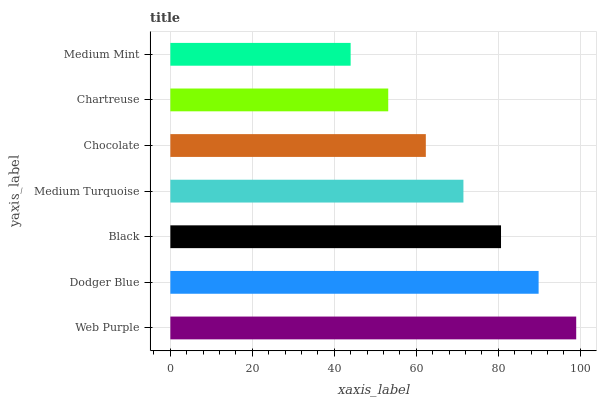Is Medium Mint the minimum?
Answer yes or no. Yes. Is Web Purple the maximum?
Answer yes or no. Yes. Is Dodger Blue the minimum?
Answer yes or no. No. Is Dodger Blue the maximum?
Answer yes or no. No. Is Web Purple greater than Dodger Blue?
Answer yes or no. Yes. Is Dodger Blue less than Web Purple?
Answer yes or no. Yes. Is Dodger Blue greater than Web Purple?
Answer yes or no. No. Is Web Purple less than Dodger Blue?
Answer yes or no. No. Is Medium Turquoise the high median?
Answer yes or no. Yes. Is Medium Turquoise the low median?
Answer yes or no. Yes. Is Medium Mint the high median?
Answer yes or no. No. Is Black the low median?
Answer yes or no. No. 